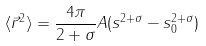Convert formula to latex. <formula><loc_0><loc_0><loc_500><loc_500>\langle \vec { r } ^ { 2 } \rangle = \frac { 4 \pi } { 2 + \sigma } A ( s ^ { 2 + \sigma } - s _ { 0 } ^ { 2 + \sigma } )</formula> 